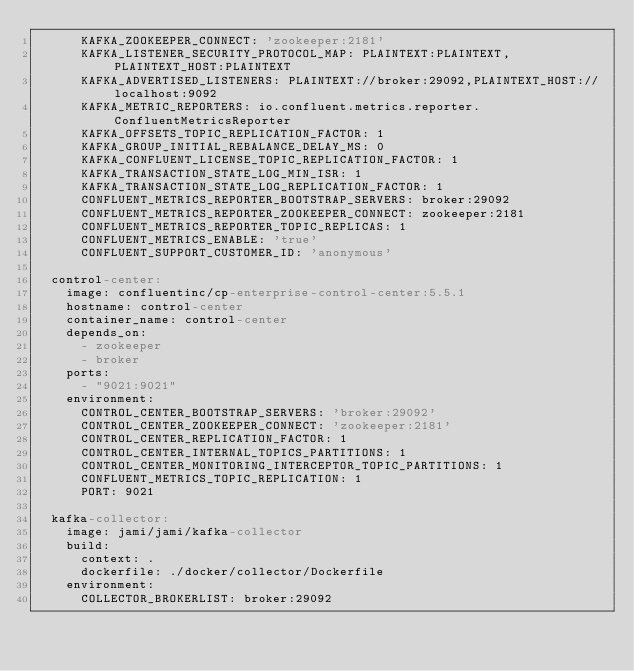<code> <loc_0><loc_0><loc_500><loc_500><_YAML_>      KAFKA_ZOOKEEPER_CONNECT: 'zookeeper:2181'
      KAFKA_LISTENER_SECURITY_PROTOCOL_MAP: PLAINTEXT:PLAINTEXT,PLAINTEXT_HOST:PLAINTEXT
      KAFKA_ADVERTISED_LISTENERS: PLAINTEXT://broker:29092,PLAINTEXT_HOST://localhost:9092
      KAFKA_METRIC_REPORTERS: io.confluent.metrics.reporter.ConfluentMetricsReporter
      KAFKA_OFFSETS_TOPIC_REPLICATION_FACTOR: 1
      KAFKA_GROUP_INITIAL_REBALANCE_DELAY_MS: 0
      KAFKA_CONFLUENT_LICENSE_TOPIC_REPLICATION_FACTOR: 1
      KAFKA_TRANSACTION_STATE_LOG_MIN_ISR: 1
      KAFKA_TRANSACTION_STATE_LOG_REPLICATION_FACTOR: 1
      CONFLUENT_METRICS_REPORTER_BOOTSTRAP_SERVERS: broker:29092
      CONFLUENT_METRICS_REPORTER_ZOOKEEPER_CONNECT: zookeeper:2181
      CONFLUENT_METRICS_REPORTER_TOPIC_REPLICAS: 1
      CONFLUENT_METRICS_ENABLE: 'true'
      CONFLUENT_SUPPORT_CUSTOMER_ID: 'anonymous'

  control-center:
    image: confluentinc/cp-enterprise-control-center:5.5.1
    hostname: control-center
    container_name: control-center
    depends_on:
      - zookeeper
      - broker
    ports:
      - "9021:9021"
    environment:
      CONTROL_CENTER_BOOTSTRAP_SERVERS: 'broker:29092'
      CONTROL_CENTER_ZOOKEEPER_CONNECT: 'zookeeper:2181'
      CONTROL_CENTER_REPLICATION_FACTOR: 1
      CONTROL_CENTER_INTERNAL_TOPICS_PARTITIONS: 1
      CONTROL_CENTER_MONITORING_INTERCEPTOR_TOPIC_PARTITIONS: 1
      CONFLUENT_METRICS_TOPIC_REPLICATION: 1
      PORT: 9021

  kafka-collector:
    image: jami/jami/kafka-collector
    build:
      context: .
      dockerfile: ./docker/collector/Dockerfile
    environment:
      COLLECTOR_BROKERLIST: broker:29092</code> 